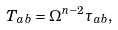<formula> <loc_0><loc_0><loc_500><loc_500>T _ { a b } = \Omega ^ { n - 2 } \tau _ { a b } ,</formula> 